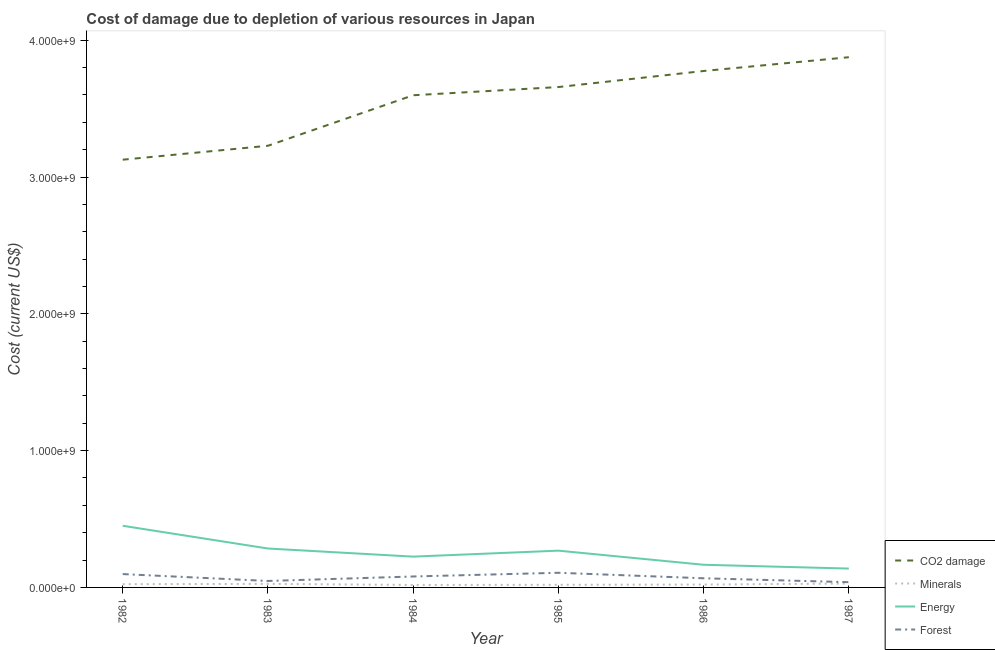How many different coloured lines are there?
Provide a short and direct response. 4. Does the line corresponding to cost of damage due to depletion of energy intersect with the line corresponding to cost of damage due to depletion of minerals?
Your answer should be very brief. No. What is the cost of damage due to depletion of coal in 1982?
Provide a succinct answer. 3.13e+09. Across all years, what is the maximum cost of damage due to depletion of forests?
Offer a terse response. 1.07e+08. Across all years, what is the minimum cost of damage due to depletion of minerals?
Give a very brief answer. 1.81e+07. What is the total cost of damage due to depletion of forests in the graph?
Provide a short and direct response. 4.37e+08. What is the difference between the cost of damage due to depletion of minerals in 1982 and that in 1985?
Make the answer very short. 4.49e+06. What is the difference between the cost of damage due to depletion of coal in 1984 and the cost of damage due to depletion of energy in 1986?
Keep it short and to the point. 3.43e+09. What is the average cost of damage due to depletion of coal per year?
Your answer should be compact. 3.54e+09. In the year 1987, what is the difference between the cost of damage due to depletion of forests and cost of damage due to depletion of coal?
Keep it short and to the point. -3.84e+09. In how many years, is the cost of damage due to depletion of energy greater than 1400000000 US$?
Give a very brief answer. 0. What is the ratio of the cost of damage due to depletion of forests in 1984 to that in 1987?
Your answer should be very brief. 2.08. What is the difference between the highest and the second highest cost of damage due to depletion of forests?
Offer a terse response. 9.52e+06. What is the difference between the highest and the lowest cost of damage due to depletion of minerals?
Ensure brevity in your answer.  1.04e+07. In how many years, is the cost of damage due to depletion of energy greater than the average cost of damage due to depletion of energy taken over all years?
Keep it short and to the point. 3. Is the sum of the cost of damage due to depletion of energy in 1984 and 1986 greater than the maximum cost of damage due to depletion of coal across all years?
Keep it short and to the point. No. Is it the case that in every year, the sum of the cost of damage due to depletion of coal and cost of damage due to depletion of forests is greater than the sum of cost of damage due to depletion of energy and cost of damage due to depletion of minerals?
Your answer should be compact. Yes. Is it the case that in every year, the sum of the cost of damage due to depletion of coal and cost of damage due to depletion of minerals is greater than the cost of damage due to depletion of energy?
Make the answer very short. Yes. Is the cost of damage due to depletion of forests strictly greater than the cost of damage due to depletion of coal over the years?
Your response must be concise. No. Is the cost of damage due to depletion of forests strictly less than the cost of damage due to depletion of coal over the years?
Your answer should be very brief. Yes. How many lines are there?
Give a very brief answer. 4. Does the graph contain any zero values?
Make the answer very short. No. Where does the legend appear in the graph?
Provide a short and direct response. Bottom right. How many legend labels are there?
Your response must be concise. 4. How are the legend labels stacked?
Offer a terse response. Vertical. What is the title of the graph?
Give a very brief answer. Cost of damage due to depletion of various resources in Japan . Does "Insurance services" appear as one of the legend labels in the graph?
Your response must be concise. No. What is the label or title of the X-axis?
Give a very brief answer. Year. What is the label or title of the Y-axis?
Give a very brief answer. Cost (current US$). What is the Cost (current US$) of CO2 damage in 1982?
Your answer should be very brief. 3.13e+09. What is the Cost (current US$) in Minerals in 1982?
Offer a terse response. 2.37e+07. What is the Cost (current US$) in Energy in 1982?
Keep it short and to the point. 4.51e+08. What is the Cost (current US$) of Forest in 1982?
Give a very brief answer. 9.75e+07. What is the Cost (current US$) of CO2 damage in 1983?
Your response must be concise. 3.23e+09. What is the Cost (current US$) in Minerals in 1983?
Your answer should be very brief. 2.60e+07. What is the Cost (current US$) in Energy in 1983?
Ensure brevity in your answer.  2.84e+08. What is the Cost (current US$) in Forest in 1983?
Offer a terse response. 4.72e+07. What is the Cost (current US$) of CO2 damage in 1984?
Provide a short and direct response. 3.60e+09. What is the Cost (current US$) of Minerals in 1984?
Keep it short and to the point. 1.81e+07. What is the Cost (current US$) in Energy in 1984?
Your answer should be compact. 2.25e+08. What is the Cost (current US$) of Forest in 1984?
Your answer should be compact. 8.00e+07. What is the Cost (current US$) in CO2 damage in 1985?
Your answer should be compact. 3.66e+09. What is the Cost (current US$) of Minerals in 1985?
Provide a succinct answer. 1.92e+07. What is the Cost (current US$) in Energy in 1985?
Offer a terse response. 2.69e+08. What is the Cost (current US$) of Forest in 1985?
Keep it short and to the point. 1.07e+08. What is the Cost (current US$) in CO2 damage in 1986?
Provide a short and direct response. 3.77e+09. What is the Cost (current US$) in Minerals in 1986?
Ensure brevity in your answer.  2.10e+07. What is the Cost (current US$) of Energy in 1986?
Provide a short and direct response. 1.66e+08. What is the Cost (current US$) of Forest in 1986?
Your answer should be compact. 6.69e+07. What is the Cost (current US$) in CO2 damage in 1987?
Your answer should be very brief. 3.88e+09. What is the Cost (current US$) of Minerals in 1987?
Your answer should be compact. 2.84e+07. What is the Cost (current US$) in Energy in 1987?
Offer a terse response. 1.38e+08. What is the Cost (current US$) in Forest in 1987?
Your response must be concise. 3.84e+07. Across all years, what is the maximum Cost (current US$) of CO2 damage?
Offer a very short reply. 3.88e+09. Across all years, what is the maximum Cost (current US$) in Minerals?
Offer a terse response. 2.84e+07. Across all years, what is the maximum Cost (current US$) in Energy?
Give a very brief answer. 4.51e+08. Across all years, what is the maximum Cost (current US$) in Forest?
Make the answer very short. 1.07e+08. Across all years, what is the minimum Cost (current US$) of CO2 damage?
Your answer should be compact. 3.13e+09. Across all years, what is the minimum Cost (current US$) of Minerals?
Give a very brief answer. 1.81e+07. Across all years, what is the minimum Cost (current US$) of Energy?
Ensure brevity in your answer.  1.38e+08. Across all years, what is the minimum Cost (current US$) in Forest?
Provide a succinct answer. 3.84e+07. What is the total Cost (current US$) in CO2 damage in the graph?
Your answer should be very brief. 2.13e+1. What is the total Cost (current US$) in Minerals in the graph?
Give a very brief answer. 1.36e+08. What is the total Cost (current US$) in Energy in the graph?
Offer a terse response. 1.53e+09. What is the total Cost (current US$) in Forest in the graph?
Provide a short and direct response. 4.37e+08. What is the difference between the Cost (current US$) of CO2 damage in 1982 and that in 1983?
Offer a terse response. -1.02e+08. What is the difference between the Cost (current US$) of Minerals in 1982 and that in 1983?
Your response must be concise. -2.31e+06. What is the difference between the Cost (current US$) of Energy in 1982 and that in 1983?
Your response must be concise. 1.66e+08. What is the difference between the Cost (current US$) of Forest in 1982 and that in 1983?
Provide a succinct answer. 5.03e+07. What is the difference between the Cost (current US$) of CO2 damage in 1982 and that in 1984?
Keep it short and to the point. -4.71e+08. What is the difference between the Cost (current US$) of Minerals in 1982 and that in 1984?
Give a very brief answer. 5.62e+06. What is the difference between the Cost (current US$) in Energy in 1982 and that in 1984?
Your answer should be compact. 2.25e+08. What is the difference between the Cost (current US$) in Forest in 1982 and that in 1984?
Ensure brevity in your answer.  1.75e+07. What is the difference between the Cost (current US$) of CO2 damage in 1982 and that in 1985?
Your answer should be compact. -5.31e+08. What is the difference between the Cost (current US$) of Minerals in 1982 and that in 1985?
Your answer should be compact. 4.49e+06. What is the difference between the Cost (current US$) of Energy in 1982 and that in 1985?
Provide a succinct answer. 1.82e+08. What is the difference between the Cost (current US$) in Forest in 1982 and that in 1985?
Ensure brevity in your answer.  -9.52e+06. What is the difference between the Cost (current US$) in CO2 damage in 1982 and that in 1986?
Offer a terse response. -6.48e+08. What is the difference between the Cost (current US$) in Minerals in 1982 and that in 1986?
Provide a short and direct response. 2.71e+06. What is the difference between the Cost (current US$) of Energy in 1982 and that in 1986?
Provide a short and direct response. 2.85e+08. What is the difference between the Cost (current US$) in Forest in 1982 and that in 1986?
Your answer should be very brief. 3.07e+07. What is the difference between the Cost (current US$) in CO2 damage in 1982 and that in 1987?
Provide a succinct answer. -7.49e+08. What is the difference between the Cost (current US$) in Minerals in 1982 and that in 1987?
Keep it short and to the point. -4.75e+06. What is the difference between the Cost (current US$) of Energy in 1982 and that in 1987?
Keep it short and to the point. 3.13e+08. What is the difference between the Cost (current US$) in Forest in 1982 and that in 1987?
Make the answer very short. 5.92e+07. What is the difference between the Cost (current US$) in CO2 damage in 1983 and that in 1984?
Provide a short and direct response. -3.69e+08. What is the difference between the Cost (current US$) of Minerals in 1983 and that in 1984?
Offer a terse response. 7.93e+06. What is the difference between the Cost (current US$) of Energy in 1983 and that in 1984?
Give a very brief answer. 5.93e+07. What is the difference between the Cost (current US$) in Forest in 1983 and that in 1984?
Offer a very short reply. -3.28e+07. What is the difference between the Cost (current US$) in CO2 damage in 1983 and that in 1985?
Provide a succinct answer. -4.29e+08. What is the difference between the Cost (current US$) of Minerals in 1983 and that in 1985?
Provide a short and direct response. 6.80e+06. What is the difference between the Cost (current US$) of Energy in 1983 and that in 1985?
Your answer should be very brief. 1.57e+07. What is the difference between the Cost (current US$) of Forest in 1983 and that in 1985?
Ensure brevity in your answer.  -5.99e+07. What is the difference between the Cost (current US$) in CO2 damage in 1983 and that in 1986?
Provide a short and direct response. -5.47e+08. What is the difference between the Cost (current US$) of Minerals in 1983 and that in 1986?
Ensure brevity in your answer.  5.02e+06. What is the difference between the Cost (current US$) of Energy in 1983 and that in 1986?
Make the answer very short. 1.19e+08. What is the difference between the Cost (current US$) of Forest in 1983 and that in 1986?
Your response must be concise. -1.97e+07. What is the difference between the Cost (current US$) in CO2 damage in 1983 and that in 1987?
Provide a succinct answer. -6.47e+08. What is the difference between the Cost (current US$) of Minerals in 1983 and that in 1987?
Ensure brevity in your answer.  -2.44e+06. What is the difference between the Cost (current US$) in Energy in 1983 and that in 1987?
Ensure brevity in your answer.  1.47e+08. What is the difference between the Cost (current US$) of Forest in 1983 and that in 1987?
Ensure brevity in your answer.  8.83e+06. What is the difference between the Cost (current US$) in CO2 damage in 1984 and that in 1985?
Ensure brevity in your answer.  -5.99e+07. What is the difference between the Cost (current US$) in Minerals in 1984 and that in 1985?
Keep it short and to the point. -1.13e+06. What is the difference between the Cost (current US$) in Energy in 1984 and that in 1985?
Ensure brevity in your answer.  -4.36e+07. What is the difference between the Cost (current US$) in Forest in 1984 and that in 1985?
Make the answer very short. -2.71e+07. What is the difference between the Cost (current US$) of CO2 damage in 1984 and that in 1986?
Your answer should be very brief. -1.77e+08. What is the difference between the Cost (current US$) in Minerals in 1984 and that in 1986?
Make the answer very short. -2.91e+06. What is the difference between the Cost (current US$) of Energy in 1984 and that in 1986?
Provide a succinct answer. 5.96e+07. What is the difference between the Cost (current US$) in Forest in 1984 and that in 1986?
Ensure brevity in your answer.  1.31e+07. What is the difference between the Cost (current US$) in CO2 damage in 1984 and that in 1987?
Keep it short and to the point. -2.78e+08. What is the difference between the Cost (current US$) in Minerals in 1984 and that in 1987?
Offer a terse response. -1.04e+07. What is the difference between the Cost (current US$) of Energy in 1984 and that in 1987?
Keep it short and to the point. 8.73e+07. What is the difference between the Cost (current US$) of Forest in 1984 and that in 1987?
Offer a very short reply. 4.16e+07. What is the difference between the Cost (current US$) of CO2 damage in 1985 and that in 1986?
Ensure brevity in your answer.  -1.17e+08. What is the difference between the Cost (current US$) in Minerals in 1985 and that in 1986?
Provide a short and direct response. -1.78e+06. What is the difference between the Cost (current US$) in Energy in 1985 and that in 1986?
Make the answer very short. 1.03e+08. What is the difference between the Cost (current US$) of Forest in 1985 and that in 1986?
Your answer should be compact. 4.02e+07. What is the difference between the Cost (current US$) in CO2 damage in 1985 and that in 1987?
Your response must be concise. -2.18e+08. What is the difference between the Cost (current US$) in Minerals in 1985 and that in 1987?
Offer a very short reply. -9.24e+06. What is the difference between the Cost (current US$) of Energy in 1985 and that in 1987?
Provide a succinct answer. 1.31e+08. What is the difference between the Cost (current US$) of Forest in 1985 and that in 1987?
Offer a very short reply. 6.87e+07. What is the difference between the Cost (current US$) of CO2 damage in 1986 and that in 1987?
Ensure brevity in your answer.  -1.01e+08. What is the difference between the Cost (current US$) in Minerals in 1986 and that in 1987?
Offer a very short reply. -7.46e+06. What is the difference between the Cost (current US$) in Energy in 1986 and that in 1987?
Your answer should be compact. 2.77e+07. What is the difference between the Cost (current US$) of Forest in 1986 and that in 1987?
Ensure brevity in your answer.  2.85e+07. What is the difference between the Cost (current US$) of CO2 damage in 1982 and the Cost (current US$) of Minerals in 1983?
Provide a succinct answer. 3.10e+09. What is the difference between the Cost (current US$) of CO2 damage in 1982 and the Cost (current US$) of Energy in 1983?
Provide a succinct answer. 2.84e+09. What is the difference between the Cost (current US$) of CO2 damage in 1982 and the Cost (current US$) of Forest in 1983?
Your answer should be compact. 3.08e+09. What is the difference between the Cost (current US$) of Minerals in 1982 and the Cost (current US$) of Energy in 1983?
Ensure brevity in your answer.  -2.61e+08. What is the difference between the Cost (current US$) of Minerals in 1982 and the Cost (current US$) of Forest in 1983?
Give a very brief answer. -2.35e+07. What is the difference between the Cost (current US$) of Energy in 1982 and the Cost (current US$) of Forest in 1983?
Make the answer very short. 4.03e+08. What is the difference between the Cost (current US$) in CO2 damage in 1982 and the Cost (current US$) in Minerals in 1984?
Your response must be concise. 3.11e+09. What is the difference between the Cost (current US$) of CO2 damage in 1982 and the Cost (current US$) of Energy in 1984?
Give a very brief answer. 2.90e+09. What is the difference between the Cost (current US$) in CO2 damage in 1982 and the Cost (current US$) in Forest in 1984?
Make the answer very short. 3.05e+09. What is the difference between the Cost (current US$) in Minerals in 1982 and the Cost (current US$) in Energy in 1984?
Ensure brevity in your answer.  -2.01e+08. What is the difference between the Cost (current US$) of Minerals in 1982 and the Cost (current US$) of Forest in 1984?
Your answer should be very brief. -5.63e+07. What is the difference between the Cost (current US$) in Energy in 1982 and the Cost (current US$) in Forest in 1984?
Give a very brief answer. 3.71e+08. What is the difference between the Cost (current US$) of CO2 damage in 1982 and the Cost (current US$) of Minerals in 1985?
Your answer should be very brief. 3.11e+09. What is the difference between the Cost (current US$) in CO2 damage in 1982 and the Cost (current US$) in Energy in 1985?
Make the answer very short. 2.86e+09. What is the difference between the Cost (current US$) in CO2 damage in 1982 and the Cost (current US$) in Forest in 1985?
Your answer should be very brief. 3.02e+09. What is the difference between the Cost (current US$) of Minerals in 1982 and the Cost (current US$) of Energy in 1985?
Your answer should be very brief. -2.45e+08. What is the difference between the Cost (current US$) of Minerals in 1982 and the Cost (current US$) of Forest in 1985?
Keep it short and to the point. -8.34e+07. What is the difference between the Cost (current US$) in Energy in 1982 and the Cost (current US$) in Forest in 1985?
Offer a terse response. 3.44e+08. What is the difference between the Cost (current US$) in CO2 damage in 1982 and the Cost (current US$) in Minerals in 1986?
Offer a terse response. 3.11e+09. What is the difference between the Cost (current US$) in CO2 damage in 1982 and the Cost (current US$) in Energy in 1986?
Provide a short and direct response. 2.96e+09. What is the difference between the Cost (current US$) in CO2 damage in 1982 and the Cost (current US$) in Forest in 1986?
Your response must be concise. 3.06e+09. What is the difference between the Cost (current US$) in Minerals in 1982 and the Cost (current US$) in Energy in 1986?
Your answer should be very brief. -1.42e+08. What is the difference between the Cost (current US$) of Minerals in 1982 and the Cost (current US$) of Forest in 1986?
Your answer should be very brief. -4.32e+07. What is the difference between the Cost (current US$) in Energy in 1982 and the Cost (current US$) in Forest in 1986?
Your response must be concise. 3.84e+08. What is the difference between the Cost (current US$) of CO2 damage in 1982 and the Cost (current US$) of Minerals in 1987?
Provide a succinct answer. 3.10e+09. What is the difference between the Cost (current US$) of CO2 damage in 1982 and the Cost (current US$) of Energy in 1987?
Offer a terse response. 2.99e+09. What is the difference between the Cost (current US$) in CO2 damage in 1982 and the Cost (current US$) in Forest in 1987?
Your answer should be very brief. 3.09e+09. What is the difference between the Cost (current US$) in Minerals in 1982 and the Cost (current US$) in Energy in 1987?
Provide a succinct answer. -1.14e+08. What is the difference between the Cost (current US$) in Minerals in 1982 and the Cost (current US$) in Forest in 1987?
Your response must be concise. -1.47e+07. What is the difference between the Cost (current US$) in Energy in 1982 and the Cost (current US$) in Forest in 1987?
Give a very brief answer. 4.12e+08. What is the difference between the Cost (current US$) in CO2 damage in 1983 and the Cost (current US$) in Minerals in 1984?
Keep it short and to the point. 3.21e+09. What is the difference between the Cost (current US$) in CO2 damage in 1983 and the Cost (current US$) in Energy in 1984?
Offer a terse response. 3.00e+09. What is the difference between the Cost (current US$) of CO2 damage in 1983 and the Cost (current US$) of Forest in 1984?
Ensure brevity in your answer.  3.15e+09. What is the difference between the Cost (current US$) in Minerals in 1983 and the Cost (current US$) in Energy in 1984?
Provide a succinct answer. -1.99e+08. What is the difference between the Cost (current US$) in Minerals in 1983 and the Cost (current US$) in Forest in 1984?
Provide a succinct answer. -5.40e+07. What is the difference between the Cost (current US$) of Energy in 1983 and the Cost (current US$) of Forest in 1984?
Offer a very short reply. 2.04e+08. What is the difference between the Cost (current US$) in CO2 damage in 1983 and the Cost (current US$) in Minerals in 1985?
Your answer should be very brief. 3.21e+09. What is the difference between the Cost (current US$) in CO2 damage in 1983 and the Cost (current US$) in Energy in 1985?
Provide a short and direct response. 2.96e+09. What is the difference between the Cost (current US$) in CO2 damage in 1983 and the Cost (current US$) in Forest in 1985?
Your answer should be very brief. 3.12e+09. What is the difference between the Cost (current US$) of Minerals in 1983 and the Cost (current US$) of Energy in 1985?
Provide a short and direct response. -2.43e+08. What is the difference between the Cost (current US$) in Minerals in 1983 and the Cost (current US$) in Forest in 1985?
Provide a succinct answer. -8.11e+07. What is the difference between the Cost (current US$) in Energy in 1983 and the Cost (current US$) in Forest in 1985?
Keep it short and to the point. 1.77e+08. What is the difference between the Cost (current US$) in CO2 damage in 1983 and the Cost (current US$) in Minerals in 1986?
Give a very brief answer. 3.21e+09. What is the difference between the Cost (current US$) of CO2 damage in 1983 and the Cost (current US$) of Energy in 1986?
Give a very brief answer. 3.06e+09. What is the difference between the Cost (current US$) in CO2 damage in 1983 and the Cost (current US$) in Forest in 1986?
Offer a terse response. 3.16e+09. What is the difference between the Cost (current US$) of Minerals in 1983 and the Cost (current US$) of Energy in 1986?
Your response must be concise. -1.40e+08. What is the difference between the Cost (current US$) in Minerals in 1983 and the Cost (current US$) in Forest in 1986?
Keep it short and to the point. -4.09e+07. What is the difference between the Cost (current US$) in Energy in 1983 and the Cost (current US$) in Forest in 1986?
Keep it short and to the point. 2.18e+08. What is the difference between the Cost (current US$) of CO2 damage in 1983 and the Cost (current US$) of Minerals in 1987?
Your answer should be compact. 3.20e+09. What is the difference between the Cost (current US$) of CO2 damage in 1983 and the Cost (current US$) of Energy in 1987?
Offer a very short reply. 3.09e+09. What is the difference between the Cost (current US$) of CO2 damage in 1983 and the Cost (current US$) of Forest in 1987?
Make the answer very short. 3.19e+09. What is the difference between the Cost (current US$) in Minerals in 1983 and the Cost (current US$) in Energy in 1987?
Offer a terse response. -1.12e+08. What is the difference between the Cost (current US$) of Minerals in 1983 and the Cost (current US$) of Forest in 1987?
Keep it short and to the point. -1.24e+07. What is the difference between the Cost (current US$) in Energy in 1983 and the Cost (current US$) in Forest in 1987?
Offer a terse response. 2.46e+08. What is the difference between the Cost (current US$) in CO2 damage in 1984 and the Cost (current US$) in Minerals in 1985?
Your answer should be compact. 3.58e+09. What is the difference between the Cost (current US$) of CO2 damage in 1984 and the Cost (current US$) of Energy in 1985?
Your answer should be very brief. 3.33e+09. What is the difference between the Cost (current US$) in CO2 damage in 1984 and the Cost (current US$) in Forest in 1985?
Offer a terse response. 3.49e+09. What is the difference between the Cost (current US$) of Minerals in 1984 and the Cost (current US$) of Energy in 1985?
Give a very brief answer. -2.51e+08. What is the difference between the Cost (current US$) in Minerals in 1984 and the Cost (current US$) in Forest in 1985?
Provide a short and direct response. -8.90e+07. What is the difference between the Cost (current US$) of Energy in 1984 and the Cost (current US$) of Forest in 1985?
Offer a terse response. 1.18e+08. What is the difference between the Cost (current US$) in CO2 damage in 1984 and the Cost (current US$) in Minerals in 1986?
Provide a succinct answer. 3.58e+09. What is the difference between the Cost (current US$) in CO2 damage in 1984 and the Cost (current US$) in Energy in 1986?
Keep it short and to the point. 3.43e+09. What is the difference between the Cost (current US$) of CO2 damage in 1984 and the Cost (current US$) of Forest in 1986?
Give a very brief answer. 3.53e+09. What is the difference between the Cost (current US$) of Minerals in 1984 and the Cost (current US$) of Energy in 1986?
Offer a very short reply. -1.48e+08. What is the difference between the Cost (current US$) of Minerals in 1984 and the Cost (current US$) of Forest in 1986?
Offer a very short reply. -4.88e+07. What is the difference between the Cost (current US$) of Energy in 1984 and the Cost (current US$) of Forest in 1986?
Make the answer very short. 1.58e+08. What is the difference between the Cost (current US$) in CO2 damage in 1984 and the Cost (current US$) in Minerals in 1987?
Provide a succinct answer. 3.57e+09. What is the difference between the Cost (current US$) in CO2 damage in 1984 and the Cost (current US$) in Energy in 1987?
Make the answer very short. 3.46e+09. What is the difference between the Cost (current US$) in CO2 damage in 1984 and the Cost (current US$) in Forest in 1987?
Your answer should be very brief. 3.56e+09. What is the difference between the Cost (current US$) in Minerals in 1984 and the Cost (current US$) in Energy in 1987?
Your answer should be very brief. -1.20e+08. What is the difference between the Cost (current US$) in Minerals in 1984 and the Cost (current US$) in Forest in 1987?
Make the answer very short. -2.03e+07. What is the difference between the Cost (current US$) of Energy in 1984 and the Cost (current US$) of Forest in 1987?
Ensure brevity in your answer.  1.87e+08. What is the difference between the Cost (current US$) in CO2 damage in 1985 and the Cost (current US$) in Minerals in 1986?
Make the answer very short. 3.64e+09. What is the difference between the Cost (current US$) of CO2 damage in 1985 and the Cost (current US$) of Energy in 1986?
Your answer should be very brief. 3.49e+09. What is the difference between the Cost (current US$) in CO2 damage in 1985 and the Cost (current US$) in Forest in 1986?
Provide a succinct answer. 3.59e+09. What is the difference between the Cost (current US$) in Minerals in 1985 and the Cost (current US$) in Energy in 1986?
Your answer should be compact. -1.46e+08. What is the difference between the Cost (current US$) of Minerals in 1985 and the Cost (current US$) of Forest in 1986?
Make the answer very short. -4.77e+07. What is the difference between the Cost (current US$) in Energy in 1985 and the Cost (current US$) in Forest in 1986?
Offer a terse response. 2.02e+08. What is the difference between the Cost (current US$) of CO2 damage in 1985 and the Cost (current US$) of Minerals in 1987?
Give a very brief answer. 3.63e+09. What is the difference between the Cost (current US$) in CO2 damage in 1985 and the Cost (current US$) in Energy in 1987?
Your answer should be compact. 3.52e+09. What is the difference between the Cost (current US$) in CO2 damage in 1985 and the Cost (current US$) in Forest in 1987?
Your answer should be very brief. 3.62e+09. What is the difference between the Cost (current US$) in Minerals in 1985 and the Cost (current US$) in Energy in 1987?
Offer a terse response. -1.19e+08. What is the difference between the Cost (current US$) of Minerals in 1985 and the Cost (current US$) of Forest in 1987?
Provide a succinct answer. -1.92e+07. What is the difference between the Cost (current US$) in Energy in 1985 and the Cost (current US$) in Forest in 1987?
Provide a succinct answer. 2.30e+08. What is the difference between the Cost (current US$) of CO2 damage in 1986 and the Cost (current US$) of Minerals in 1987?
Provide a short and direct response. 3.75e+09. What is the difference between the Cost (current US$) in CO2 damage in 1986 and the Cost (current US$) in Energy in 1987?
Your answer should be compact. 3.64e+09. What is the difference between the Cost (current US$) in CO2 damage in 1986 and the Cost (current US$) in Forest in 1987?
Provide a succinct answer. 3.74e+09. What is the difference between the Cost (current US$) in Minerals in 1986 and the Cost (current US$) in Energy in 1987?
Make the answer very short. -1.17e+08. What is the difference between the Cost (current US$) in Minerals in 1986 and the Cost (current US$) in Forest in 1987?
Your response must be concise. -1.74e+07. What is the difference between the Cost (current US$) in Energy in 1986 and the Cost (current US$) in Forest in 1987?
Ensure brevity in your answer.  1.27e+08. What is the average Cost (current US$) in CO2 damage per year?
Keep it short and to the point. 3.54e+09. What is the average Cost (current US$) in Minerals per year?
Offer a very short reply. 2.27e+07. What is the average Cost (current US$) of Energy per year?
Offer a terse response. 2.55e+08. What is the average Cost (current US$) in Forest per year?
Your answer should be very brief. 7.28e+07. In the year 1982, what is the difference between the Cost (current US$) of CO2 damage and Cost (current US$) of Minerals?
Offer a terse response. 3.10e+09. In the year 1982, what is the difference between the Cost (current US$) in CO2 damage and Cost (current US$) in Energy?
Provide a succinct answer. 2.68e+09. In the year 1982, what is the difference between the Cost (current US$) in CO2 damage and Cost (current US$) in Forest?
Your response must be concise. 3.03e+09. In the year 1982, what is the difference between the Cost (current US$) in Minerals and Cost (current US$) in Energy?
Offer a terse response. -4.27e+08. In the year 1982, what is the difference between the Cost (current US$) in Minerals and Cost (current US$) in Forest?
Offer a very short reply. -7.38e+07. In the year 1982, what is the difference between the Cost (current US$) in Energy and Cost (current US$) in Forest?
Offer a terse response. 3.53e+08. In the year 1983, what is the difference between the Cost (current US$) in CO2 damage and Cost (current US$) in Minerals?
Provide a succinct answer. 3.20e+09. In the year 1983, what is the difference between the Cost (current US$) in CO2 damage and Cost (current US$) in Energy?
Give a very brief answer. 2.94e+09. In the year 1983, what is the difference between the Cost (current US$) of CO2 damage and Cost (current US$) of Forest?
Provide a succinct answer. 3.18e+09. In the year 1983, what is the difference between the Cost (current US$) of Minerals and Cost (current US$) of Energy?
Give a very brief answer. -2.58e+08. In the year 1983, what is the difference between the Cost (current US$) in Minerals and Cost (current US$) in Forest?
Give a very brief answer. -2.12e+07. In the year 1983, what is the difference between the Cost (current US$) of Energy and Cost (current US$) of Forest?
Your answer should be compact. 2.37e+08. In the year 1984, what is the difference between the Cost (current US$) of CO2 damage and Cost (current US$) of Minerals?
Your response must be concise. 3.58e+09. In the year 1984, what is the difference between the Cost (current US$) in CO2 damage and Cost (current US$) in Energy?
Your response must be concise. 3.37e+09. In the year 1984, what is the difference between the Cost (current US$) in CO2 damage and Cost (current US$) in Forest?
Keep it short and to the point. 3.52e+09. In the year 1984, what is the difference between the Cost (current US$) in Minerals and Cost (current US$) in Energy?
Provide a succinct answer. -2.07e+08. In the year 1984, what is the difference between the Cost (current US$) in Minerals and Cost (current US$) in Forest?
Ensure brevity in your answer.  -6.19e+07. In the year 1984, what is the difference between the Cost (current US$) of Energy and Cost (current US$) of Forest?
Provide a short and direct response. 1.45e+08. In the year 1985, what is the difference between the Cost (current US$) of CO2 damage and Cost (current US$) of Minerals?
Keep it short and to the point. 3.64e+09. In the year 1985, what is the difference between the Cost (current US$) of CO2 damage and Cost (current US$) of Energy?
Your answer should be very brief. 3.39e+09. In the year 1985, what is the difference between the Cost (current US$) in CO2 damage and Cost (current US$) in Forest?
Provide a short and direct response. 3.55e+09. In the year 1985, what is the difference between the Cost (current US$) in Minerals and Cost (current US$) in Energy?
Your response must be concise. -2.50e+08. In the year 1985, what is the difference between the Cost (current US$) of Minerals and Cost (current US$) of Forest?
Offer a terse response. -8.79e+07. In the year 1985, what is the difference between the Cost (current US$) in Energy and Cost (current US$) in Forest?
Give a very brief answer. 1.62e+08. In the year 1986, what is the difference between the Cost (current US$) in CO2 damage and Cost (current US$) in Minerals?
Offer a very short reply. 3.75e+09. In the year 1986, what is the difference between the Cost (current US$) in CO2 damage and Cost (current US$) in Energy?
Provide a short and direct response. 3.61e+09. In the year 1986, what is the difference between the Cost (current US$) in CO2 damage and Cost (current US$) in Forest?
Your answer should be compact. 3.71e+09. In the year 1986, what is the difference between the Cost (current US$) in Minerals and Cost (current US$) in Energy?
Your answer should be very brief. -1.45e+08. In the year 1986, what is the difference between the Cost (current US$) in Minerals and Cost (current US$) in Forest?
Offer a terse response. -4.59e+07. In the year 1986, what is the difference between the Cost (current US$) of Energy and Cost (current US$) of Forest?
Keep it short and to the point. 9.87e+07. In the year 1987, what is the difference between the Cost (current US$) in CO2 damage and Cost (current US$) in Minerals?
Ensure brevity in your answer.  3.85e+09. In the year 1987, what is the difference between the Cost (current US$) of CO2 damage and Cost (current US$) of Energy?
Provide a short and direct response. 3.74e+09. In the year 1987, what is the difference between the Cost (current US$) of CO2 damage and Cost (current US$) of Forest?
Offer a terse response. 3.84e+09. In the year 1987, what is the difference between the Cost (current US$) in Minerals and Cost (current US$) in Energy?
Make the answer very short. -1.09e+08. In the year 1987, what is the difference between the Cost (current US$) of Minerals and Cost (current US$) of Forest?
Ensure brevity in your answer.  -9.93e+06. In the year 1987, what is the difference between the Cost (current US$) of Energy and Cost (current US$) of Forest?
Your response must be concise. 9.95e+07. What is the ratio of the Cost (current US$) of CO2 damage in 1982 to that in 1983?
Your response must be concise. 0.97. What is the ratio of the Cost (current US$) in Minerals in 1982 to that in 1983?
Make the answer very short. 0.91. What is the ratio of the Cost (current US$) of Energy in 1982 to that in 1983?
Keep it short and to the point. 1.58. What is the ratio of the Cost (current US$) in Forest in 1982 to that in 1983?
Provide a short and direct response. 2.07. What is the ratio of the Cost (current US$) in CO2 damage in 1982 to that in 1984?
Offer a terse response. 0.87. What is the ratio of the Cost (current US$) in Minerals in 1982 to that in 1984?
Make the answer very short. 1.31. What is the ratio of the Cost (current US$) in Energy in 1982 to that in 1984?
Provide a short and direct response. 2. What is the ratio of the Cost (current US$) of Forest in 1982 to that in 1984?
Keep it short and to the point. 1.22. What is the ratio of the Cost (current US$) of CO2 damage in 1982 to that in 1985?
Ensure brevity in your answer.  0.85. What is the ratio of the Cost (current US$) in Minerals in 1982 to that in 1985?
Your answer should be compact. 1.23. What is the ratio of the Cost (current US$) of Energy in 1982 to that in 1985?
Ensure brevity in your answer.  1.68. What is the ratio of the Cost (current US$) in Forest in 1982 to that in 1985?
Ensure brevity in your answer.  0.91. What is the ratio of the Cost (current US$) in CO2 damage in 1982 to that in 1986?
Ensure brevity in your answer.  0.83. What is the ratio of the Cost (current US$) in Minerals in 1982 to that in 1986?
Ensure brevity in your answer.  1.13. What is the ratio of the Cost (current US$) in Energy in 1982 to that in 1986?
Make the answer very short. 2.72. What is the ratio of the Cost (current US$) of Forest in 1982 to that in 1986?
Offer a terse response. 1.46. What is the ratio of the Cost (current US$) in CO2 damage in 1982 to that in 1987?
Make the answer very short. 0.81. What is the ratio of the Cost (current US$) in Minerals in 1982 to that in 1987?
Keep it short and to the point. 0.83. What is the ratio of the Cost (current US$) of Energy in 1982 to that in 1987?
Your answer should be very brief. 3.27. What is the ratio of the Cost (current US$) in Forest in 1982 to that in 1987?
Ensure brevity in your answer.  2.54. What is the ratio of the Cost (current US$) of CO2 damage in 1983 to that in 1984?
Provide a short and direct response. 0.9. What is the ratio of the Cost (current US$) in Minerals in 1983 to that in 1984?
Offer a terse response. 1.44. What is the ratio of the Cost (current US$) in Energy in 1983 to that in 1984?
Ensure brevity in your answer.  1.26. What is the ratio of the Cost (current US$) in Forest in 1983 to that in 1984?
Your answer should be very brief. 0.59. What is the ratio of the Cost (current US$) of CO2 damage in 1983 to that in 1985?
Provide a succinct answer. 0.88. What is the ratio of the Cost (current US$) of Minerals in 1983 to that in 1985?
Your answer should be very brief. 1.35. What is the ratio of the Cost (current US$) in Energy in 1983 to that in 1985?
Offer a very short reply. 1.06. What is the ratio of the Cost (current US$) in Forest in 1983 to that in 1985?
Provide a succinct answer. 0.44. What is the ratio of the Cost (current US$) of CO2 damage in 1983 to that in 1986?
Keep it short and to the point. 0.86. What is the ratio of the Cost (current US$) of Minerals in 1983 to that in 1986?
Offer a very short reply. 1.24. What is the ratio of the Cost (current US$) in Energy in 1983 to that in 1986?
Provide a short and direct response. 1.72. What is the ratio of the Cost (current US$) of Forest in 1983 to that in 1986?
Your response must be concise. 0.71. What is the ratio of the Cost (current US$) in CO2 damage in 1983 to that in 1987?
Ensure brevity in your answer.  0.83. What is the ratio of the Cost (current US$) in Minerals in 1983 to that in 1987?
Your answer should be compact. 0.91. What is the ratio of the Cost (current US$) of Energy in 1983 to that in 1987?
Offer a very short reply. 2.06. What is the ratio of the Cost (current US$) of Forest in 1983 to that in 1987?
Offer a terse response. 1.23. What is the ratio of the Cost (current US$) in CO2 damage in 1984 to that in 1985?
Your response must be concise. 0.98. What is the ratio of the Cost (current US$) in Energy in 1984 to that in 1985?
Provide a short and direct response. 0.84. What is the ratio of the Cost (current US$) in Forest in 1984 to that in 1985?
Offer a very short reply. 0.75. What is the ratio of the Cost (current US$) of CO2 damage in 1984 to that in 1986?
Your answer should be compact. 0.95. What is the ratio of the Cost (current US$) in Minerals in 1984 to that in 1986?
Provide a succinct answer. 0.86. What is the ratio of the Cost (current US$) in Energy in 1984 to that in 1986?
Your response must be concise. 1.36. What is the ratio of the Cost (current US$) of Forest in 1984 to that in 1986?
Your answer should be compact. 1.2. What is the ratio of the Cost (current US$) in CO2 damage in 1984 to that in 1987?
Keep it short and to the point. 0.93. What is the ratio of the Cost (current US$) of Minerals in 1984 to that in 1987?
Your answer should be compact. 0.64. What is the ratio of the Cost (current US$) in Energy in 1984 to that in 1987?
Give a very brief answer. 1.63. What is the ratio of the Cost (current US$) in Forest in 1984 to that in 1987?
Keep it short and to the point. 2.08. What is the ratio of the Cost (current US$) in CO2 damage in 1985 to that in 1986?
Make the answer very short. 0.97. What is the ratio of the Cost (current US$) in Minerals in 1985 to that in 1986?
Make the answer very short. 0.92. What is the ratio of the Cost (current US$) of Energy in 1985 to that in 1986?
Offer a very short reply. 1.62. What is the ratio of the Cost (current US$) in Forest in 1985 to that in 1986?
Keep it short and to the point. 1.6. What is the ratio of the Cost (current US$) in CO2 damage in 1985 to that in 1987?
Offer a very short reply. 0.94. What is the ratio of the Cost (current US$) in Minerals in 1985 to that in 1987?
Offer a terse response. 0.68. What is the ratio of the Cost (current US$) in Energy in 1985 to that in 1987?
Offer a very short reply. 1.95. What is the ratio of the Cost (current US$) in Forest in 1985 to that in 1987?
Your answer should be very brief. 2.79. What is the ratio of the Cost (current US$) of CO2 damage in 1986 to that in 1987?
Your answer should be very brief. 0.97. What is the ratio of the Cost (current US$) in Minerals in 1986 to that in 1987?
Your response must be concise. 0.74. What is the ratio of the Cost (current US$) in Energy in 1986 to that in 1987?
Ensure brevity in your answer.  1.2. What is the ratio of the Cost (current US$) of Forest in 1986 to that in 1987?
Offer a terse response. 1.74. What is the difference between the highest and the second highest Cost (current US$) of CO2 damage?
Offer a very short reply. 1.01e+08. What is the difference between the highest and the second highest Cost (current US$) of Minerals?
Keep it short and to the point. 2.44e+06. What is the difference between the highest and the second highest Cost (current US$) of Energy?
Provide a succinct answer. 1.66e+08. What is the difference between the highest and the second highest Cost (current US$) of Forest?
Keep it short and to the point. 9.52e+06. What is the difference between the highest and the lowest Cost (current US$) of CO2 damage?
Give a very brief answer. 7.49e+08. What is the difference between the highest and the lowest Cost (current US$) of Minerals?
Keep it short and to the point. 1.04e+07. What is the difference between the highest and the lowest Cost (current US$) in Energy?
Your answer should be compact. 3.13e+08. What is the difference between the highest and the lowest Cost (current US$) in Forest?
Your answer should be compact. 6.87e+07. 